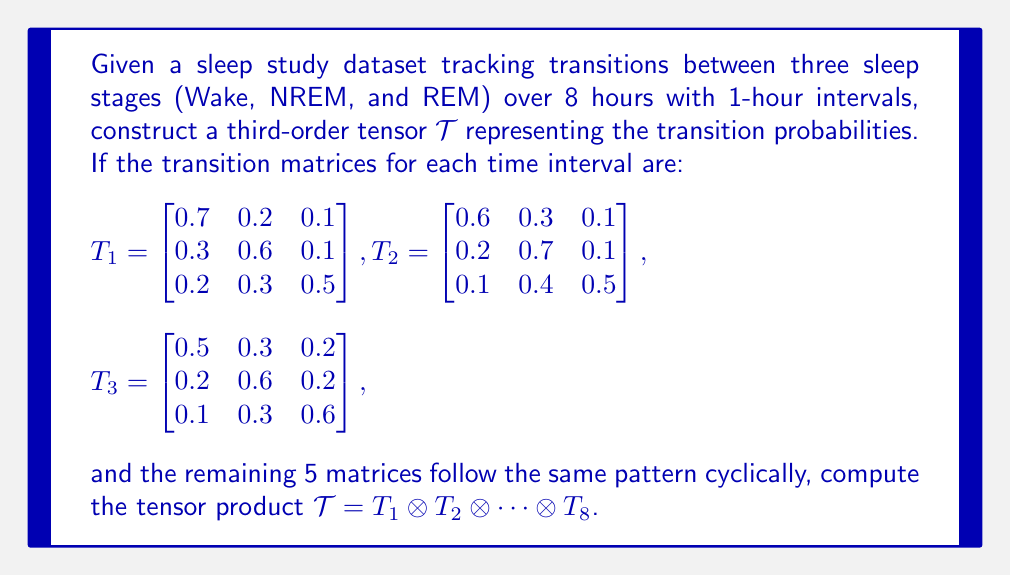Teach me how to tackle this problem. To solve this problem, we'll follow these steps:

1) First, we need to understand that the tensor product $\mathcal{T} = T_1 \otimes T_2 \otimes \cdots \otimes T_8$ will result in a third-order tensor of size $3 \times 3 \times 8$, where each "slice" along the third dimension represents the transition matrix for that time interval.

2) We're given $T_1$, $T_2$, and $T_3$. The remaining matrices will follow the same pattern cyclically:

   $T_4 = T_1$, $T_5 = T_2$, $T_6 = T_3$, $T_7 = T_1$, $T_8 = T_2$

3) The tensor product in this case is essentially stacking these matrices along the third dimension. So, our tensor $\mathcal{T}$ will look like:

   $$\mathcal{T}_{ijk} = [T_k]_{ij}$$

   where $i, j = 1, 2, 3$ and $k = 1, 2, ..., 8$

4) To represent this compactly, we can use tensor notation:

   $$\mathcal{T} = \sum_{i=1}^3 \sum_{j=1}^3 \sum_{k=1}^8 [T_k]_{ij} \mathbf{e}_i \otimes \mathbf{e}_j \otimes \mathbf{e}_k$$

   where $\mathbf{e}_i$, $\mathbf{e}_j$, and $\mathbf{e}_k$ are standard basis vectors.

5) The resulting tensor $\mathcal{T}$ will contain all transition probabilities for each sleep stage at each time interval, allowing for analysis of how these transitions change over the course of the night.
Answer: $$\mathcal{T} = \sum_{i=1}^3 \sum_{j=1}^3 \sum_{k=1}^8 [T_k]_{ij} \mathbf{e}_i \otimes \mathbf{e}_j \otimes \mathbf{e}_k$$ 